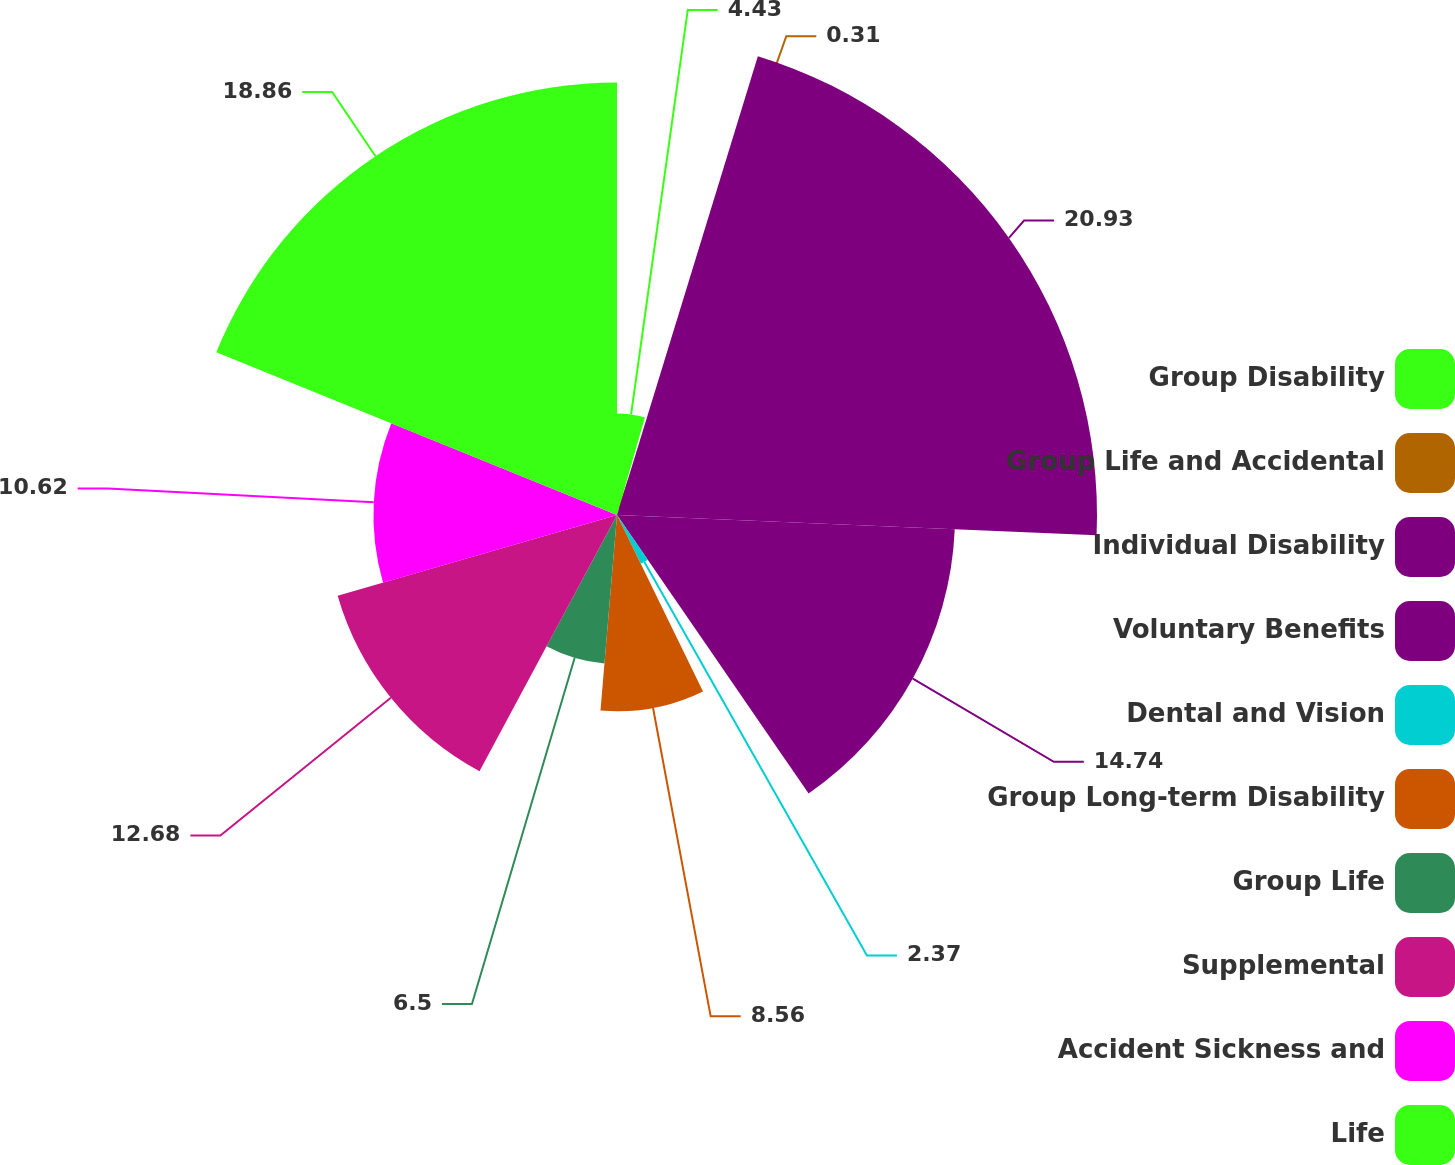Convert chart to OTSL. <chart><loc_0><loc_0><loc_500><loc_500><pie_chart><fcel>Group Disability<fcel>Group Life and Accidental<fcel>Individual Disability<fcel>Voluntary Benefits<fcel>Dental and Vision<fcel>Group Long-term Disability<fcel>Group Life<fcel>Supplemental<fcel>Accident Sickness and<fcel>Life<nl><fcel>4.43%<fcel>0.31%<fcel>20.93%<fcel>14.74%<fcel>2.37%<fcel>8.56%<fcel>6.5%<fcel>12.68%<fcel>10.62%<fcel>18.86%<nl></chart> 